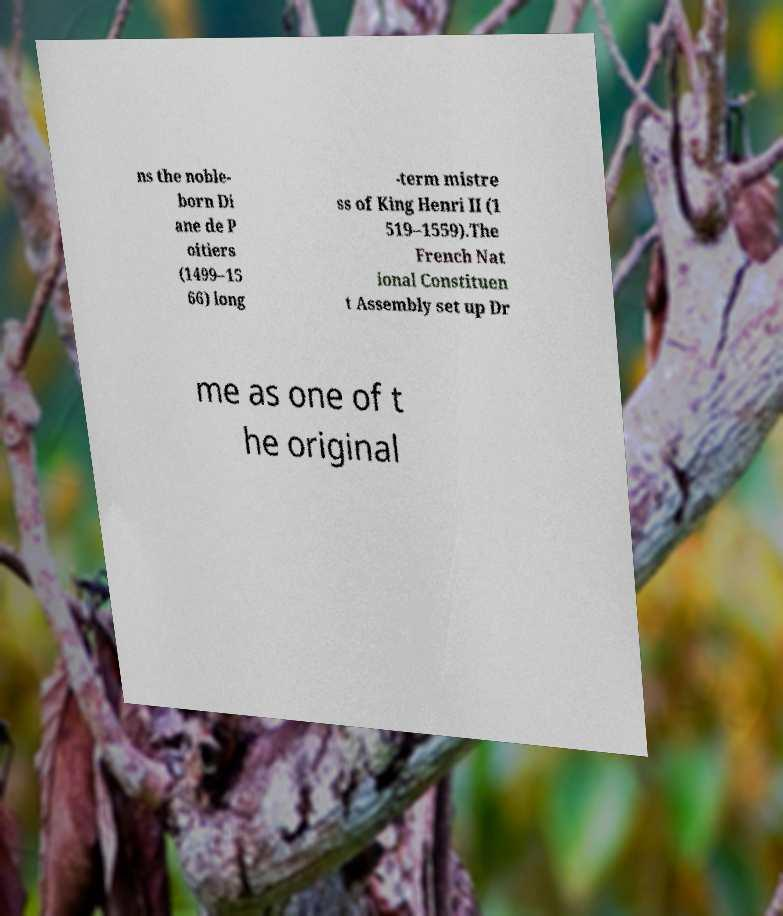Please read and relay the text visible in this image. What does it say? ns the noble- born Di ane de P oitiers (1499–15 66) long -term mistre ss of King Henri II (1 519–1559).The French Nat ional Constituen t Assembly set up Dr me as one of t he original 